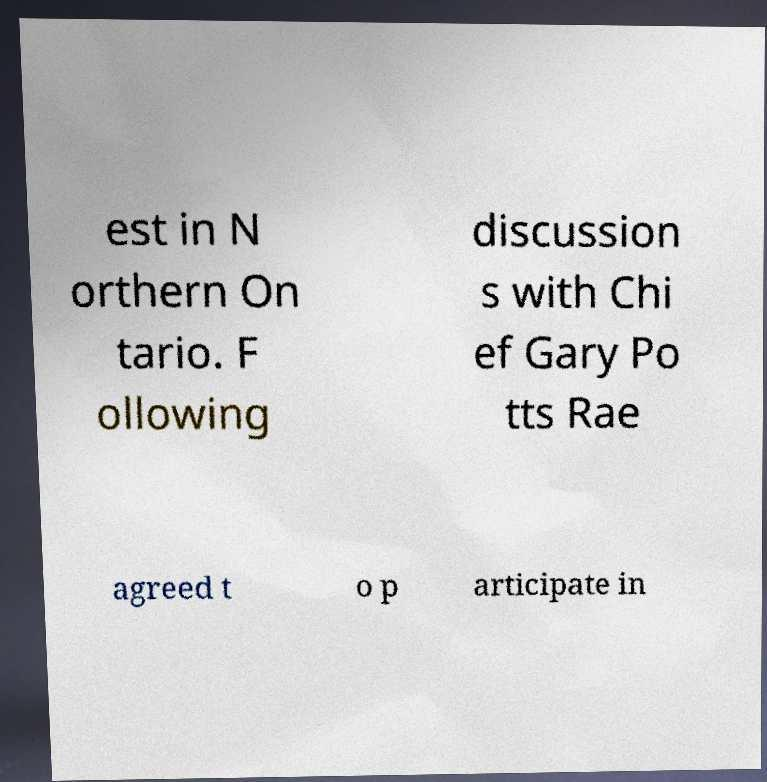Please identify and transcribe the text found in this image. est in N orthern On tario. F ollowing discussion s with Chi ef Gary Po tts Rae agreed t o p articipate in 